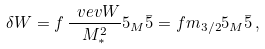Convert formula to latex. <formula><loc_0><loc_0><loc_500><loc_500>\delta W = f \, \frac { \ v e v { W } } { M _ { * } ^ { 2 } } { 5 } _ { M } { \bar { 5 } } = f m _ { 3 / 2 } { 5 } _ { M } { \bar { 5 } } \, ,</formula> 